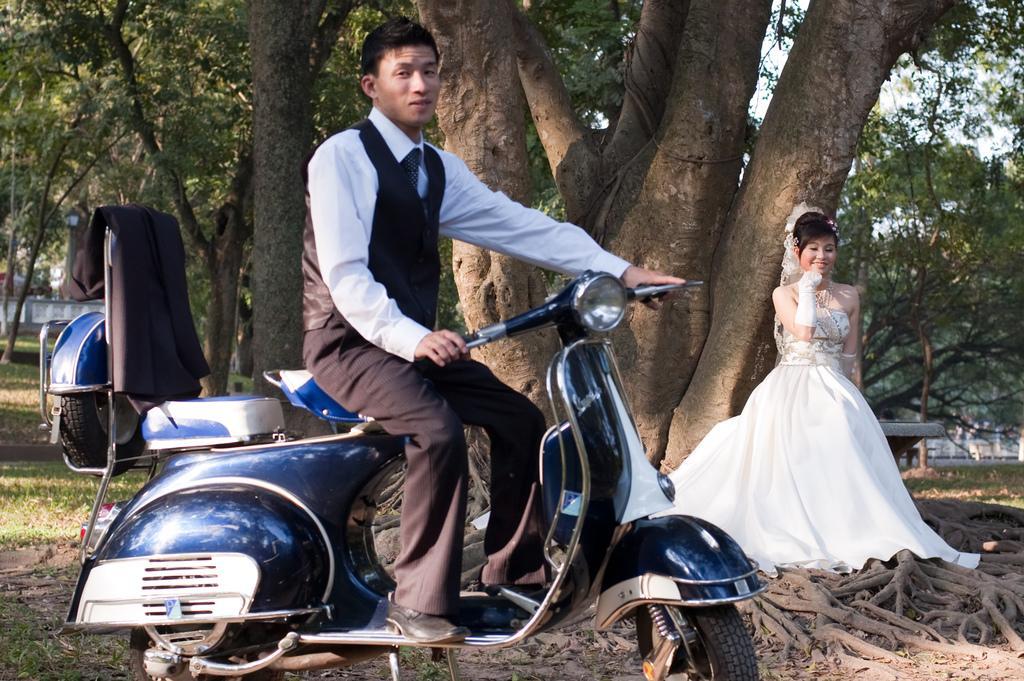Describe this image in one or two sentences. In this image, there is a person wearing clothes and sitting on the scooter. There is an another person in the middle of the image wearing clothes and standing in front of the tree. 